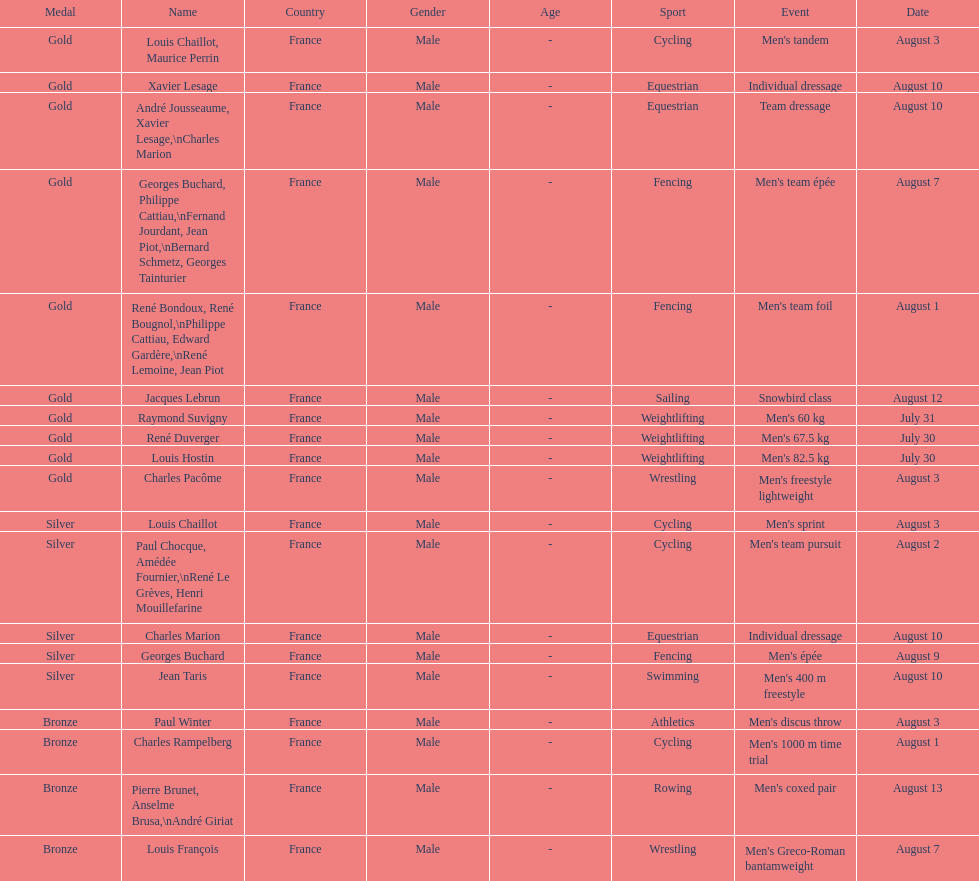How many gold medals did this country win during these olympics? 10. 